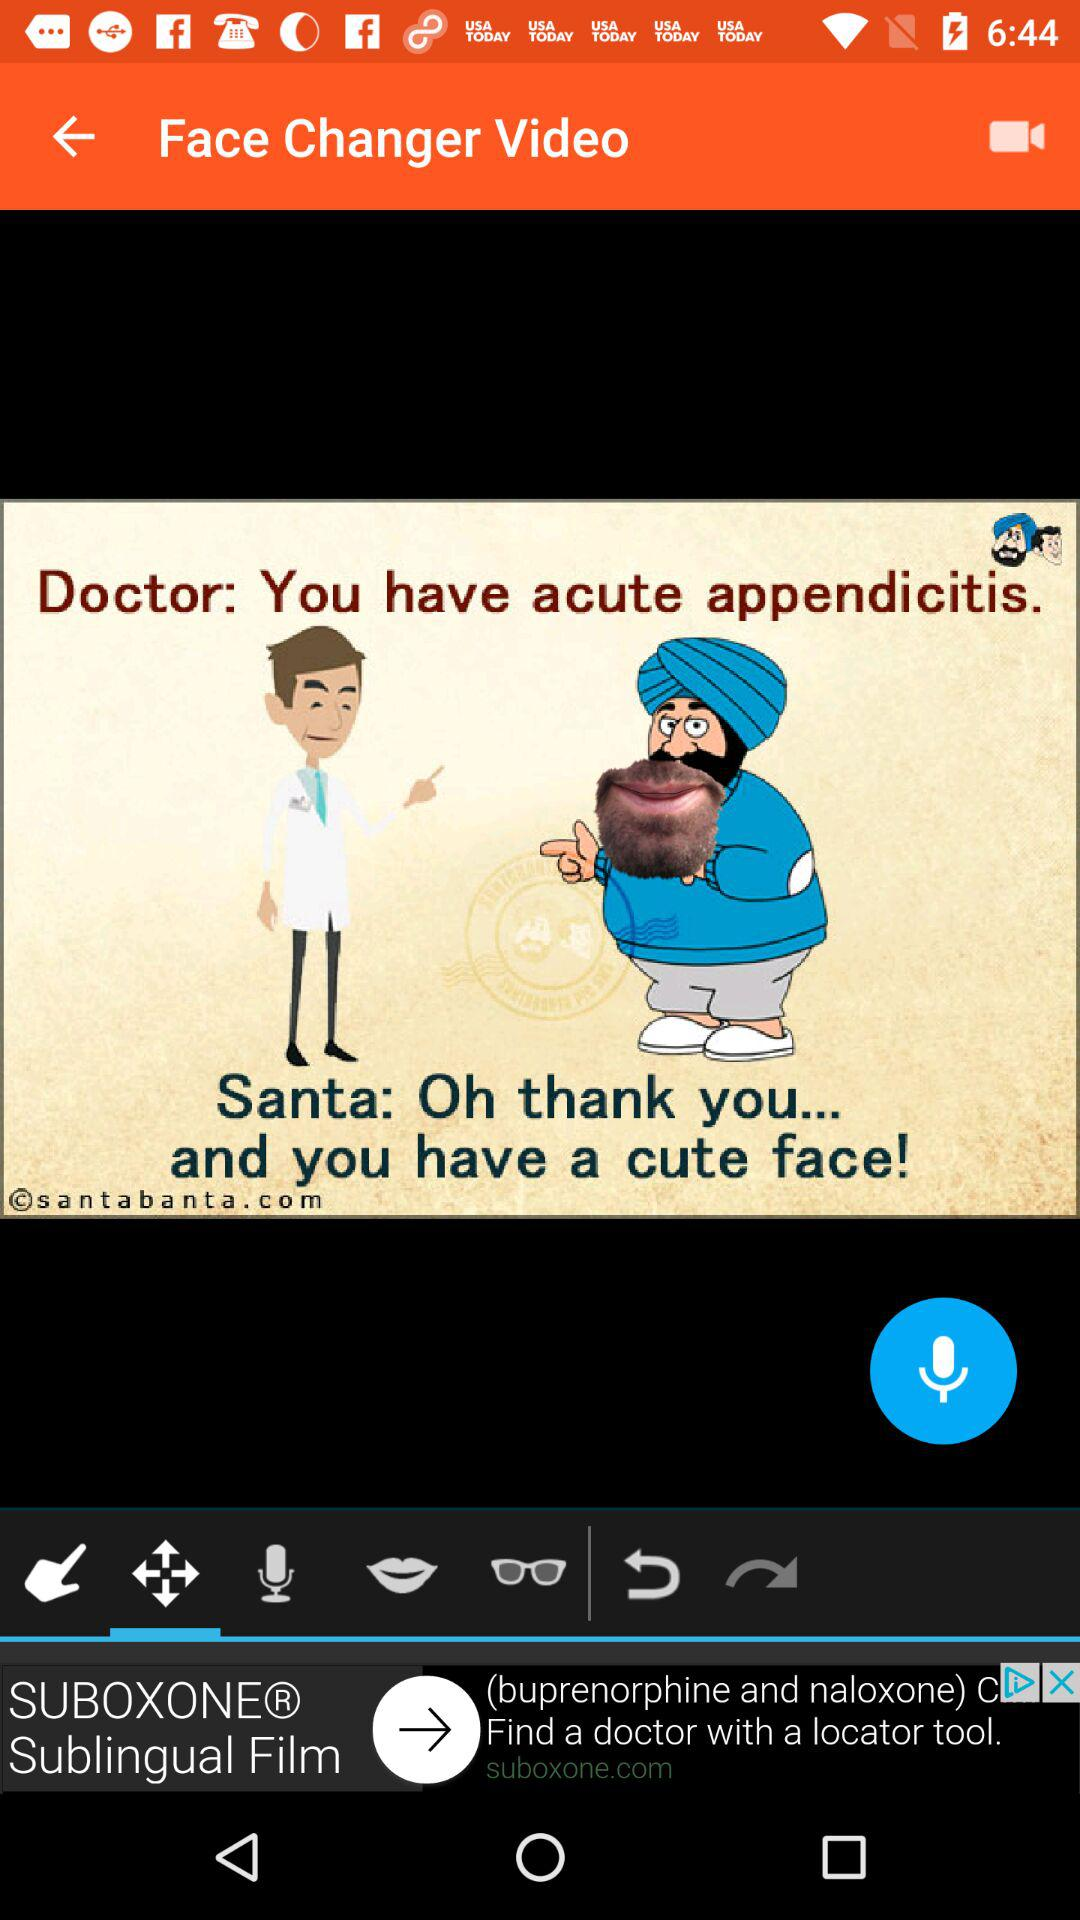What is the application name?
When the provided information is insufficient, respond with <no answer>. <no answer> 